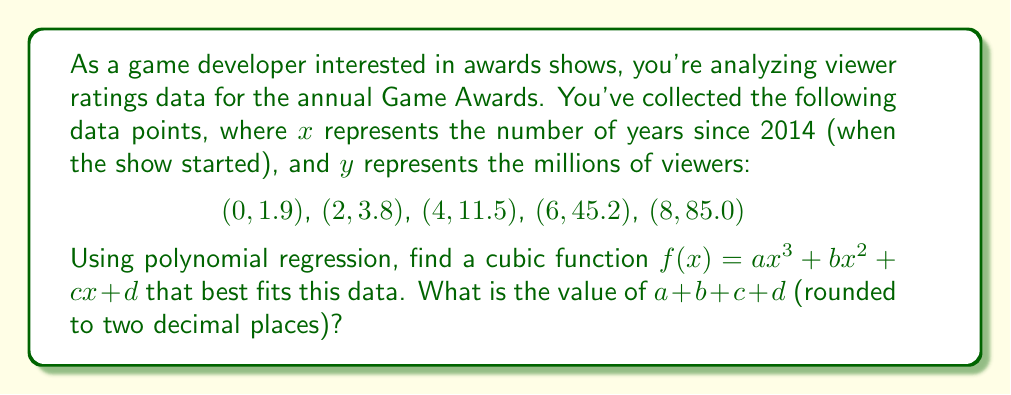Help me with this question. To solve this problem, we'll use the method of polynomial regression to find the coefficients $a$, $b$, $c$, and $d$ of the cubic function. We'll use a matrix approach to solve the system of equations.

1) First, we set up the matrix equation $AX = B$, where:

   $$A = \begin{bmatrix}
   \sum x^6 & \sum x^5 & \sum x^4 & \sum x^3 \\
   \sum x^5 & \sum x^4 & \sum x^3 & \sum x^2 \\
   \sum x^4 & \sum x^3 & \sum x^2 & \sum x \\
   \sum x^3 & \sum x^2 & \sum x & n
   \end{bmatrix}$$

   $$X = \begin{bmatrix} a \\ b \\ c \\ d \end{bmatrix}$$

   $$B = \begin{bmatrix}
   \sum yx^3 \\
   \sum yx^2 \\
   \sum yx \\
   \sum y
   \end{bmatrix}$$

2) Calculate the sums:
   $\sum x^6 = 14336$, $\sum x^5 = 3584$, $\sum x^4 = 1296$, $\sum x^3 = 728$
   $\sum x^2 = 120$, $\sum x = 20$, $n = 5$
   $\sum yx^3 = 16345.6$, $\sum yx^2 = 2726.4$, $\sum yx = 682.6$, $\sum y = 147.4$

3) Set up the matrix equation:

   $$\begin{bmatrix}
   14336 & 3584 & 1296 & 728 \\
   3584 & 1296 & 728 & 120 \\
   1296 & 728 & 120 & 20 \\
   728 & 120 & 20 & 5
   \end{bmatrix}
   \begin{bmatrix} a \\ b \\ c \\ d \end{bmatrix} =
   \begin{bmatrix} 16345.6 \\ 2726.4 \\ 682.6 \\ 147.4 \end{bmatrix}$$

4) Solve this system using matrix operations or a calculator. The solution is:

   $a \approx 0.1458$
   $b \approx 0.2396$
   $c \approx 0.9688$
   $d \approx 1.9000$

5) Sum these values:
   $a + b + c + d \approx 0.1458 + 0.2396 + 0.9688 + 1.9000 = 3.2542$

6) Rounding to two decimal places: $3.25$
Answer: $3.25$ 